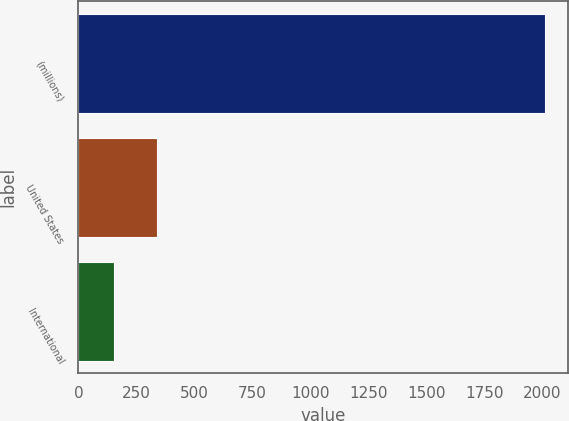<chart> <loc_0><loc_0><loc_500><loc_500><bar_chart><fcel>(millions)<fcel>United States<fcel>International<nl><fcel>2011<fcel>338.7<fcel>152.7<nl></chart> 